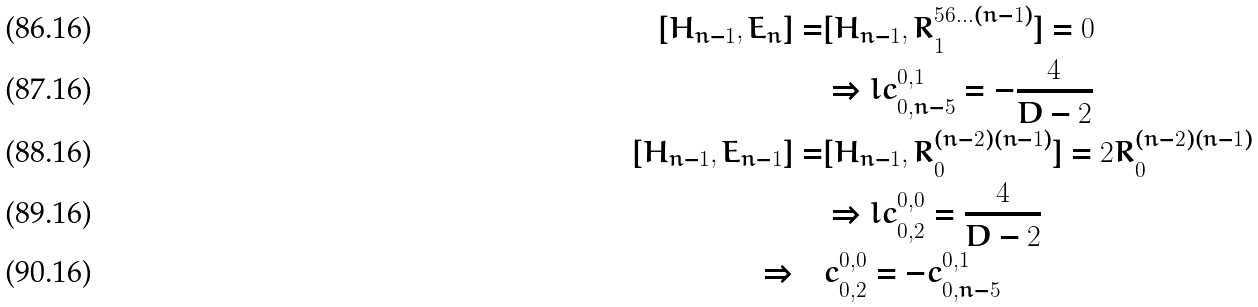<formula> <loc_0><loc_0><loc_500><loc_500>[ H _ { n - 1 } , E _ { n } ] = & [ H _ { n - 1 } , R ^ { 5 6 \dots ( n - 1 ) } _ { 1 } ] = 0 \\ & \Rightarrow l c _ { 0 , n - 5 } ^ { 0 , 1 } = - \frac { 4 } { D - 2 } \\ [ H _ { n - 1 } , E _ { n - 1 } ] = & [ H _ { n - 1 } , R ^ { ( n - 2 ) ( n - 1 ) } _ { 0 } ] = 2 R ^ { ( n - 2 ) ( n - 1 ) } _ { 0 } \\ & \Rightarrow l c _ { 0 , 2 } ^ { 0 , 0 } = \frac { 4 } { D - 2 } \\ \Rightarrow \quad & c _ { 0 , 2 } ^ { 0 , 0 } = - c _ { 0 , n - 5 } ^ { 0 , 1 }</formula> 